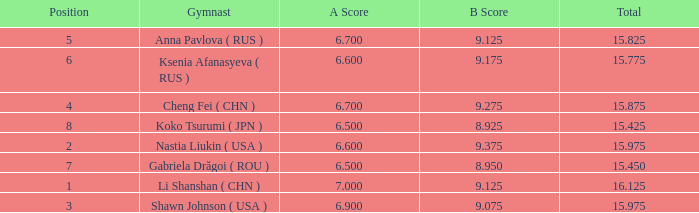What the B Score when the total is 16.125 and the position is less than 7? 9.125. 